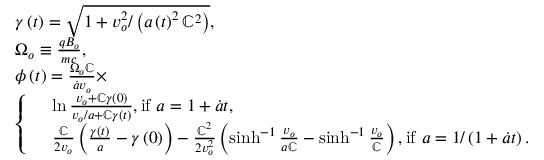Convert formula to latex. <formula><loc_0><loc_0><loc_500><loc_500>\begin{array} { r l } & { \gamma \left ( t \right ) = \sqrt { 1 + v _ { o } ^ { 2 } / \left ( a \left ( t \right ) ^ { 2 } \mathbb { C } ^ { 2 } \right ) } , } \\ & { \Omega _ { o } \equiv \frac { q B _ { o } } { m c } , } \\ & { \phi \left ( t \right ) = \frac { \Omega _ { o } \mathbb { C } } { \dot { a } v _ { o } } \times } \\ & { \left \{ \begin{array} { r l } & { \ln \frac { v _ { o } + \mathbb { C } \gamma \left ( 0 \right ) } { v _ { o } / a + \mathbb { C } \gamma \left ( t \right ) } , i f a = 1 + \dot { a } t , } \\ & { \frac { \mathbb { C } } { 2 v _ { o } } \left ( \frac { \gamma \left ( t \right ) } { a } - \gamma \left ( 0 \right ) \right ) - \frac { \mathbb { C } ^ { 2 } } { 2 v _ { o } ^ { 2 } } \left ( \sinh ^ { - 1 } \frac { v _ { o } } { a \mathbb { C } } - \sinh ^ { - 1 } \frac { v _ { o } } { \mathbb { C } } \right ) , i f a = 1 / \left ( 1 + \dot { a } t \right ) . } \end{array} } \end{array}</formula> 